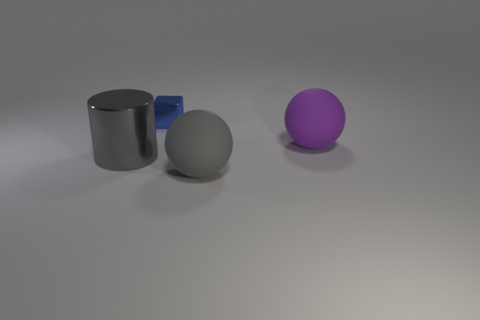Subtract all gray spheres. How many spheres are left? 1 Subtract 1 spheres. How many spheres are left? 1 Add 1 large yellow matte things. How many large yellow matte things exist? 1 Add 1 purple matte spheres. How many objects exist? 5 Subtract 0 green cubes. How many objects are left? 4 Subtract all blocks. How many objects are left? 3 Subtract all purple cylinders. Subtract all red spheres. How many cylinders are left? 1 Subtract all purple cylinders. How many purple spheres are left? 1 Subtract all large green cubes. Subtract all small blocks. How many objects are left? 3 Add 3 rubber objects. How many rubber objects are left? 5 